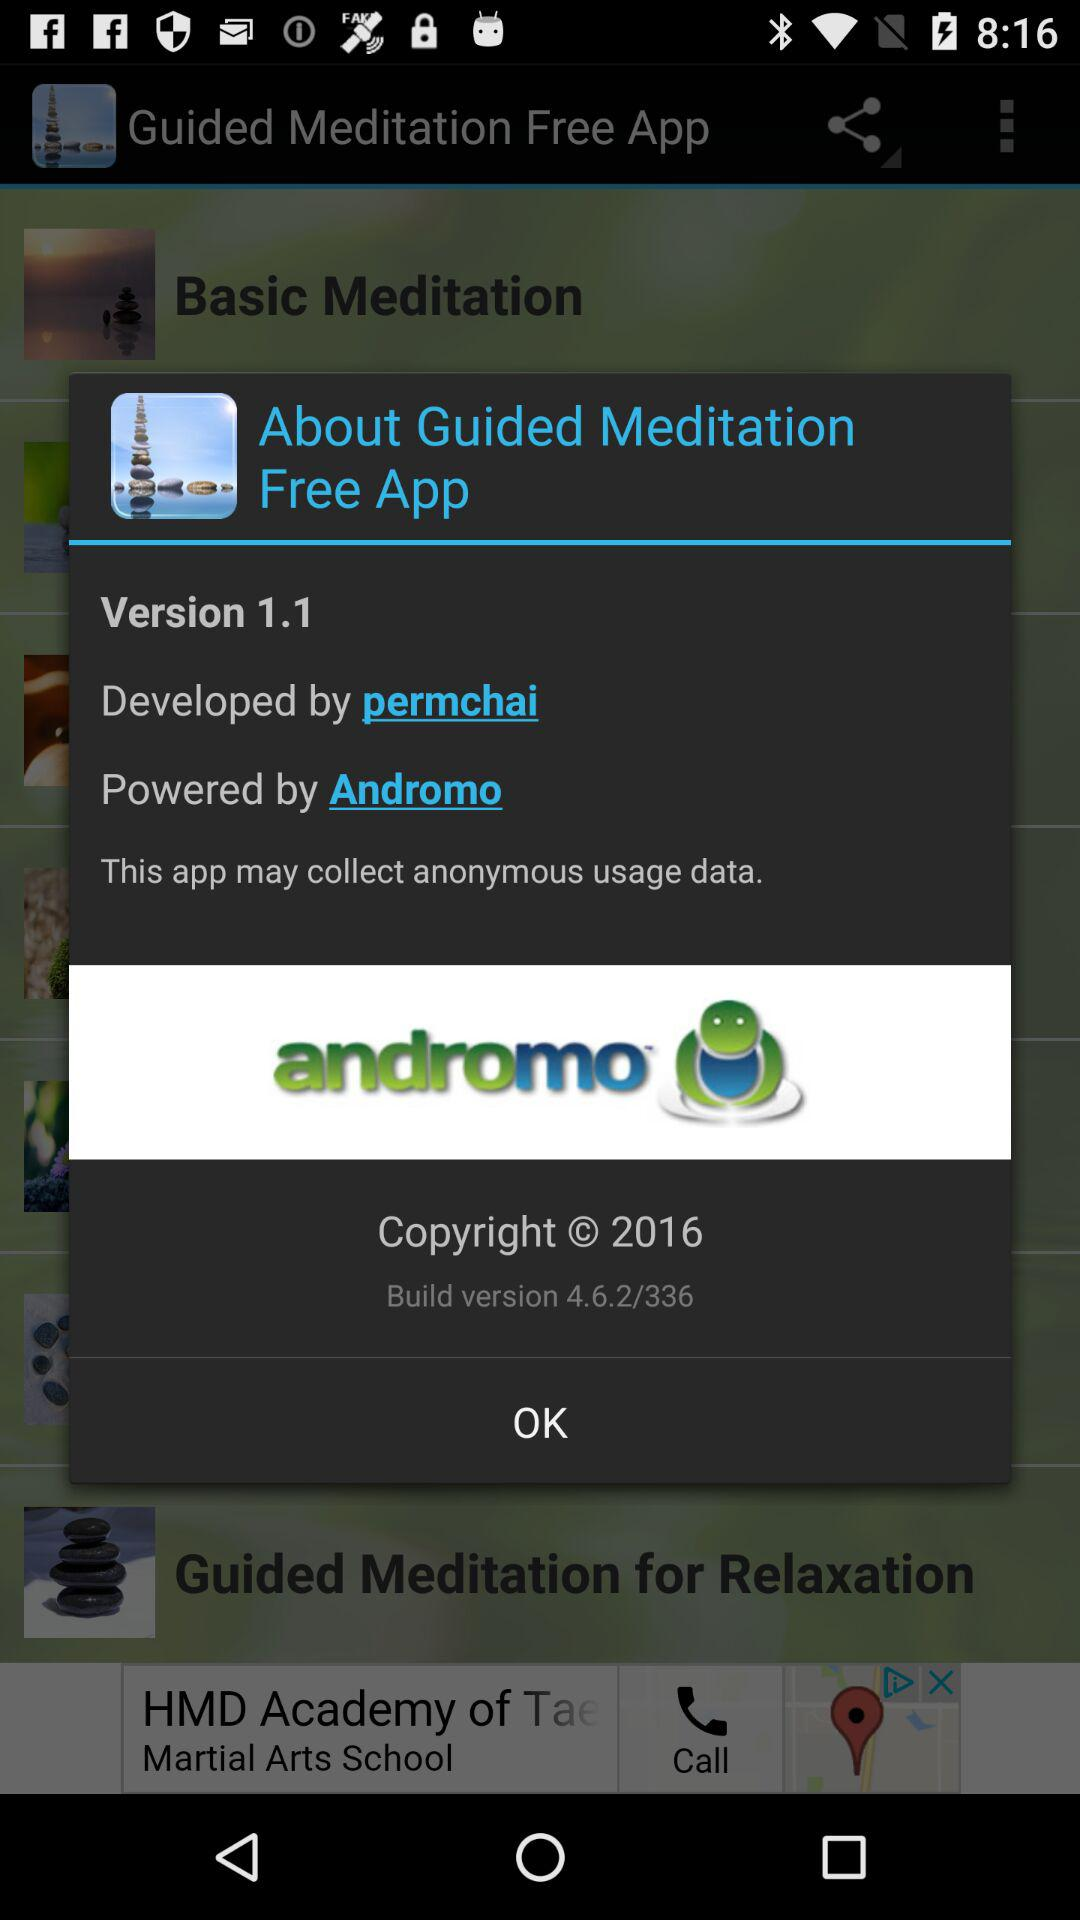What is the name of the application? The name of the application is "Guided Meditation Free App". 